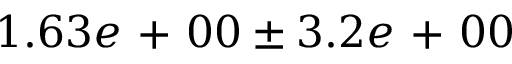<formula> <loc_0><loc_0><loc_500><loc_500>1 . 6 3 e + 0 0 \pm 3 . 2 e + 0 0</formula> 